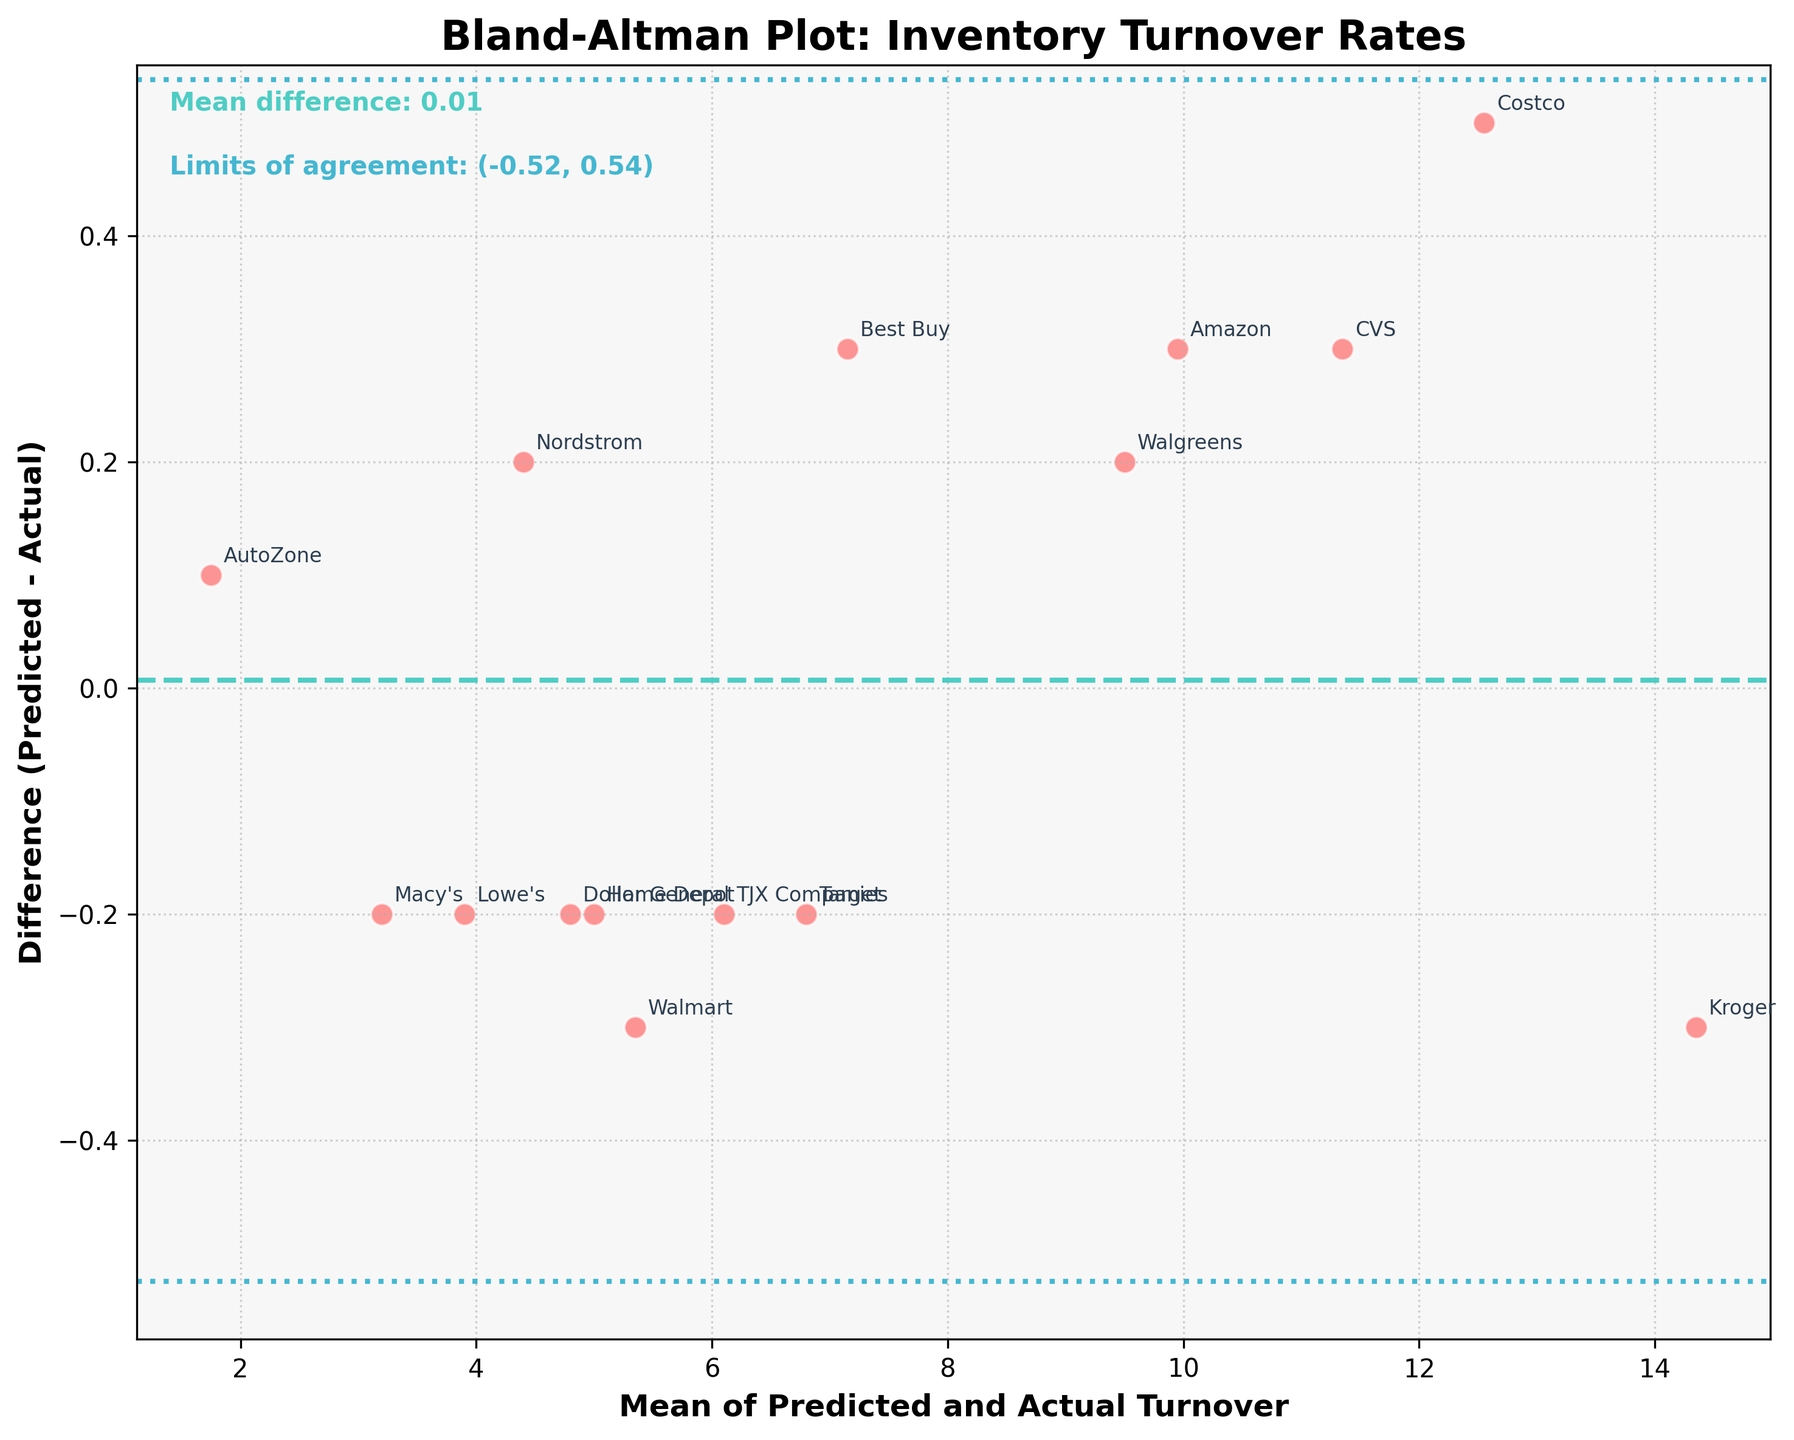What is the title of the plot? The title of the plot is displayed at the top center of the figure. It reads "Bland-Altman Plot: Inventory Turnover Rates".
Answer: Bland-Altman Plot: Inventory Turnover Rates What do the horizontal dashed and dotted lines represent? The dashed line represents the mean difference between the predicted and actual turnover rates, while the dotted lines represent the limits of agreement (mean difference ± 1.96 standard deviations).
Answer: Mean difference and limits of agreement Which supplier has the lowest mean of predicted and actual turnover? By looking at the x-axis, the supplier with the lowest mean value is the company with the smallest value on the x-axis. This supplier is AutoZone.
Answer: AutoZone What is the mean difference between predicted and actual turnover rates? The mean difference is shown as a text label inside the plot. It is approximately 0.04.
Answer: 0.04 Which supplier has the largest positive difference between predicted and actual turnover? By looking at the y-axis, the supplier with the largest positive difference has the highest point above the x-axis. This supplier is Walmart.
Answer: Walmart Do any suppliers fall outside the limits of agreement? Check if any data points fall outside the dotted lines representing the limits of agreement. No points fall outside these lines.
Answer: No What are the values for the limits of agreement? The limits of agreement are shown as a text label inside the plot. They are approximately (-0.34, 0.42).
Answer: (-0.34, 0.42) Compare the turnover rates of Costco and Kroger. Which supplier has a higher average? Locate the points for both Costco and Kroger on the plot. The mean for Costco is around 12.55 and for Kroger is around 14.35. Thus, Kroger has a higher average.
Answer: Kroger How many suppliers have a negative difference between predicted and actual turnover? Count the number of points below the horizontal dashed line. There are 7 such points.
Answer: 7 What is the correlation (qualitative) between the mean turnover rates and the differences? Observe the spread of data points. There doesn't appear to be a systematic pattern indicating a strong correlation; the differences seem fairly randomly distributed around the mean.
Answer: No strong correlation 